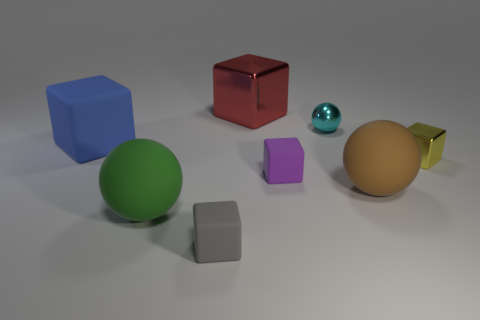How does the lighting affect the appearance of the objects? The lighting in the image appears to be coming from the upper left, casting subtle shadows to the right of the objects. This creates depth and gives the shapes a three-dimensional appearance, highlighting the texture of the surfaces, especially on the matte objects where the light diffuses softly. 